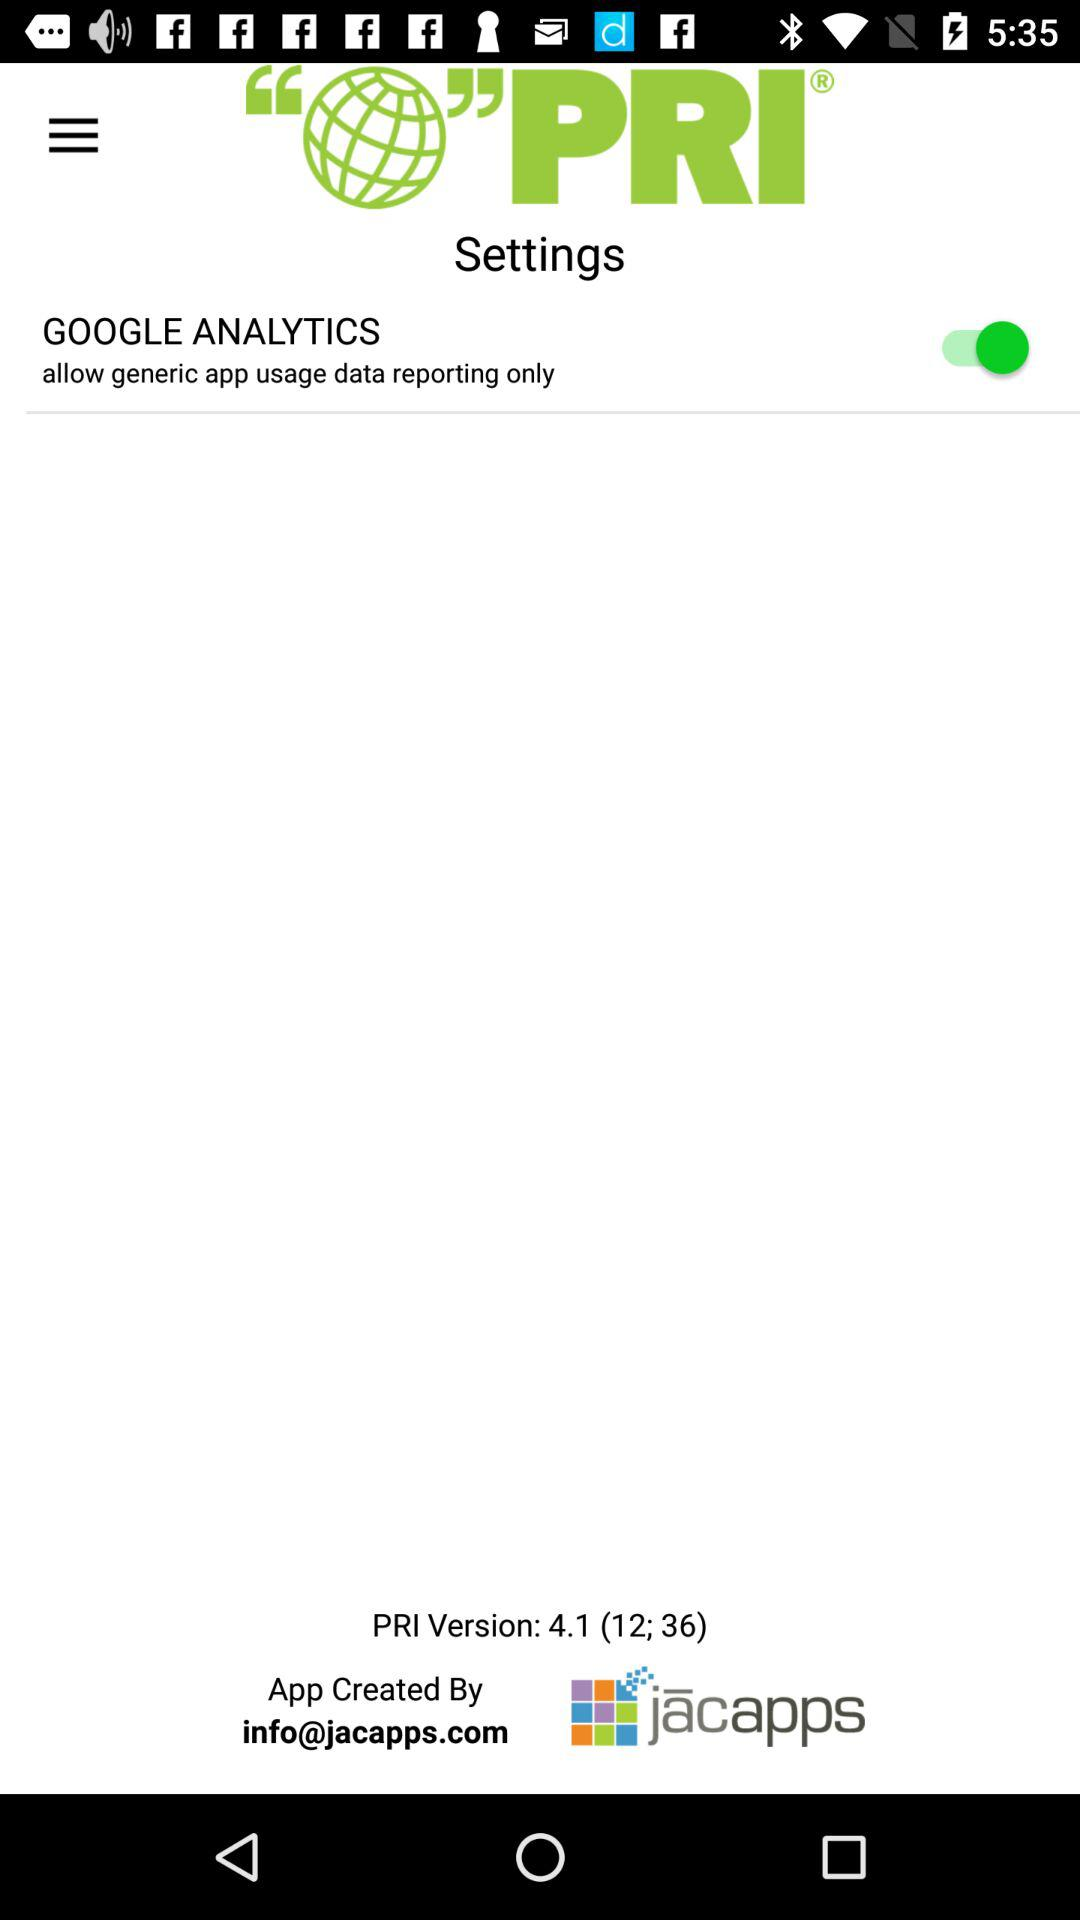What is the radio frequency of PRI?
When the provided information is insufficient, respond with <no answer>. <no answer> 